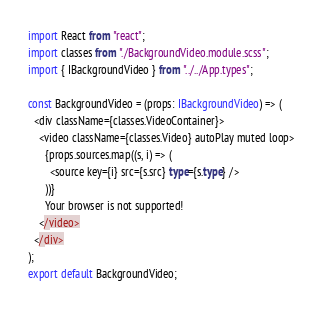<code> <loc_0><loc_0><loc_500><loc_500><_TypeScript_>import React from "react";
import classes from "./BackgroundVideo.module.scss";
import { IBackgroundVideo } from "../../App.types";

const BackgroundVideo = (props: IBackgroundVideo) => (
  <div className={classes.VideoContainer}>
    <video className={classes.Video} autoPlay muted loop>
      {props.sources.map((s, i) => (
        <source key={i} src={s.src} type={s.type} />
      ))}
      Your browser is not supported!
    </video>
  </div>
);
export default BackgroundVideo;
</code> 